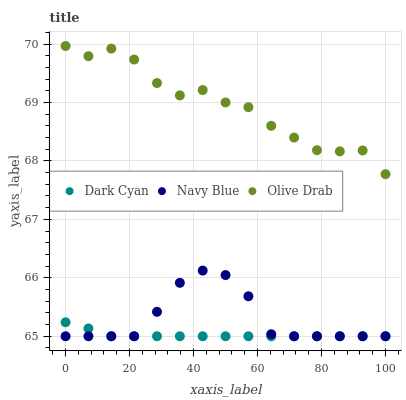Does Dark Cyan have the minimum area under the curve?
Answer yes or no. Yes. Does Olive Drab have the maximum area under the curve?
Answer yes or no. Yes. Does Navy Blue have the minimum area under the curve?
Answer yes or no. No. Does Navy Blue have the maximum area under the curve?
Answer yes or no. No. Is Dark Cyan the smoothest?
Answer yes or no. Yes. Is Olive Drab the roughest?
Answer yes or no. Yes. Is Navy Blue the smoothest?
Answer yes or no. No. Is Navy Blue the roughest?
Answer yes or no. No. Does Dark Cyan have the lowest value?
Answer yes or no. Yes. Does Olive Drab have the lowest value?
Answer yes or no. No. Does Olive Drab have the highest value?
Answer yes or no. Yes. Does Navy Blue have the highest value?
Answer yes or no. No. Is Navy Blue less than Olive Drab?
Answer yes or no. Yes. Is Olive Drab greater than Navy Blue?
Answer yes or no. Yes. Does Dark Cyan intersect Navy Blue?
Answer yes or no. Yes. Is Dark Cyan less than Navy Blue?
Answer yes or no. No. Is Dark Cyan greater than Navy Blue?
Answer yes or no. No. Does Navy Blue intersect Olive Drab?
Answer yes or no. No. 